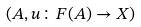Convert formula to latex. <formula><loc_0><loc_0><loc_500><loc_500>( A , u \colon F ( A ) \to X )</formula> 